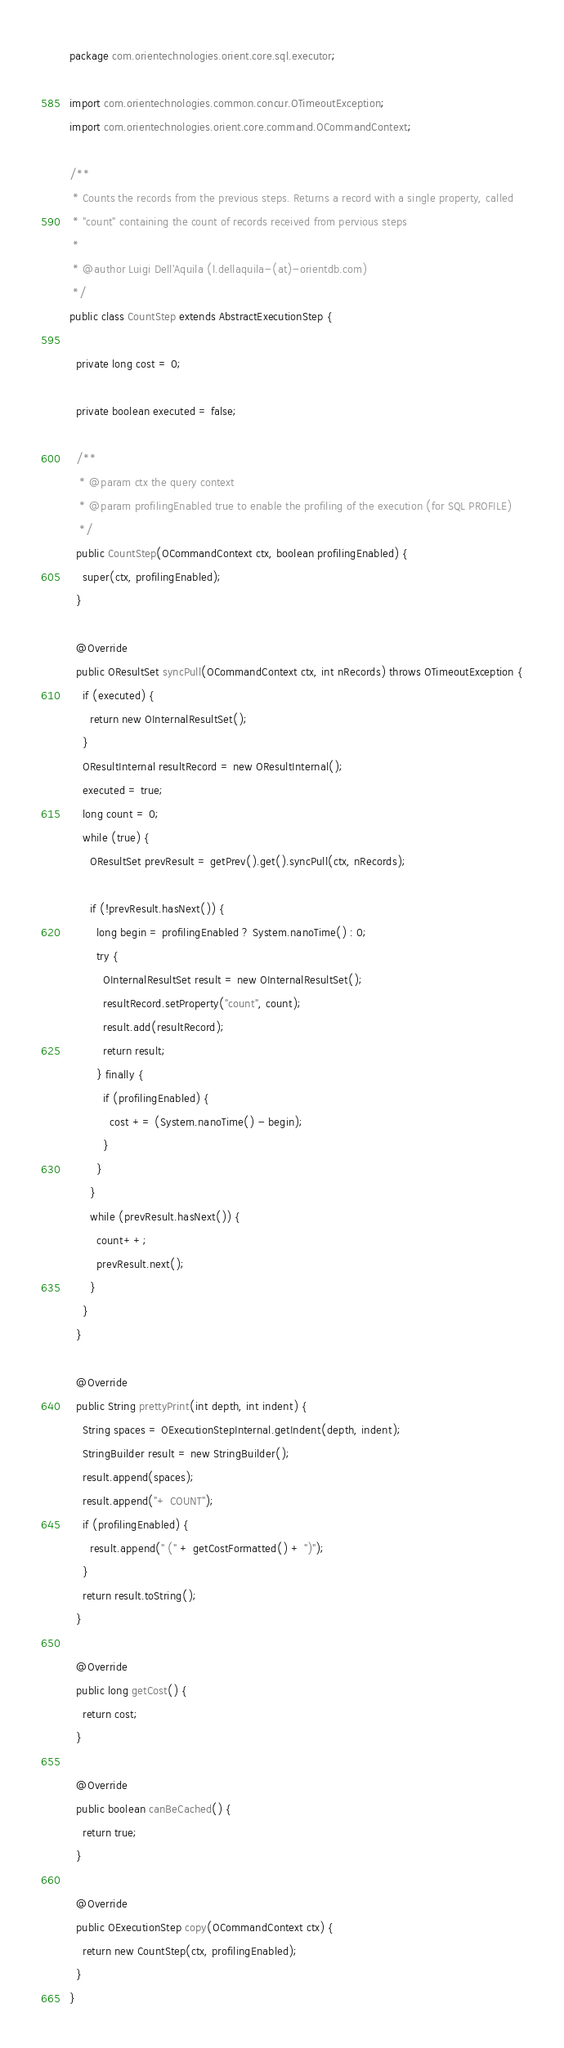<code> <loc_0><loc_0><loc_500><loc_500><_Java_>package com.orientechnologies.orient.core.sql.executor;

import com.orientechnologies.common.concur.OTimeoutException;
import com.orientechnologies.orient.core.command.OCommandContext;

/**
 * Counts the records from the previous steps. Returns a record with a single property, called
 * "count" containing the count of records received from pervious steps
 *
 * @author Luigi Dell'Aquila (l.dellaquila-(at)-orientdb.com)
 */
public class CountStep extends AbstractExecutionStep {

  private long cost = 0;

  private boolean executed = false;

  /**
   * @param ctx the query context
   * @param profilingEnabled true to enable the profiling of the execution (for SQL PROFILE)
   */
  public CountStep(OCommandContext ctx, boolean profilingEnabled) {
    super(ctx, profilingEnabled);
  }

  @Override
  public OResultSet syncPull(OCommandContext ctx, int nRecords) throws OTimeoutException {
    if (executed) {
      return new OInternalResultSet();
    }
    OResultInternal resultRecord = new OResultInternal();
    executed = true;
    long count = 0;
    while (true) {
      OResultSet prevResult = getPrev().get().syncPull(ctx, nRecords);

      if (!prevResult.hasNext()) {
        long begin = profilingEnabled ? System.nanoTime() : 0;
        try {
          OInternalResultSet result = new OInternalResultSet();
          resultRecord.setProperty("count", count);
          result.add(resultRecord);
          return result;
        } finally {
          if (profilingEnabled) {
            cost += (System.nanoTime() - begin);
          }
        }
      }
      while (prevResult.hasNext()) {
        count++;
        prevResult.next();
      }
    }
  }

  @Override
  public String prettyPrint(int depth, int indent) {
    String spaces = OExecutionStepInternal.getIndent(depth, indent);
    StringBuilder result = new StringBuilder();
    result.append(spaces);
    result.append("+ COUNT");
    if (profilingEnabled) {
      result.append(" (" + getCostFormatted() + ")");
    }
    return result.toString();
  }

  @Override
  public long getCost() {
    return cost;
  }

  @Override
  public boolean canBeCached() {
    return true;
  }

  @Override
  public OExecutionStep copy(OCommandContext ctx) {
    return new CountStep(ctx, profilingEnabled);
  }
}
</code> 